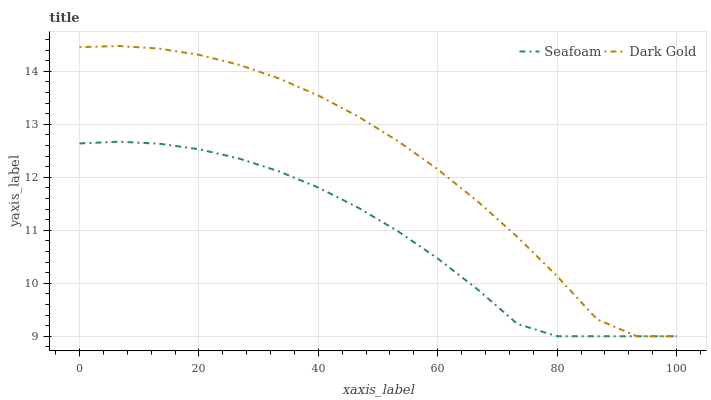Does Seafoam have the minimum area under the curve?
Answer yes or no. Yes. Does Dark Gold have the maximum area under the curve?
Answer yes or no. Yes. Does Dark Gold have the minimum area under the curve?
Answer yes or no. No. Is Seafoam the smoothest?
Answer yes or no. Yes. Is Dark Gold the roughest?
Answer yes or no. Yes. Is Dark Gold the smoothest?
Answer yes or no. No. Does Seafoam have the lowest value?
Answer yes or no. Yes. Does Dark Gold have the highest value?
Answer yes or no. Yes. Does Seafoam intersect Dark Gold?
Answer yes or no. Yes. Is Seafoam less than Dark Gold?
Answer yes or no. No. Is Seafoam greater than Dark Gold?
Answer yes or no. No. 